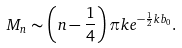Convert formula to latex. <formula><loc_0><loc_0><loc_500><loc_500>M _ { n } \sim \left ( n - \frac { 1 } { 4 } \right ) \pi k e ^ { - \frac { 1 } { 2 } k b _ { 0 } } .</formula> 